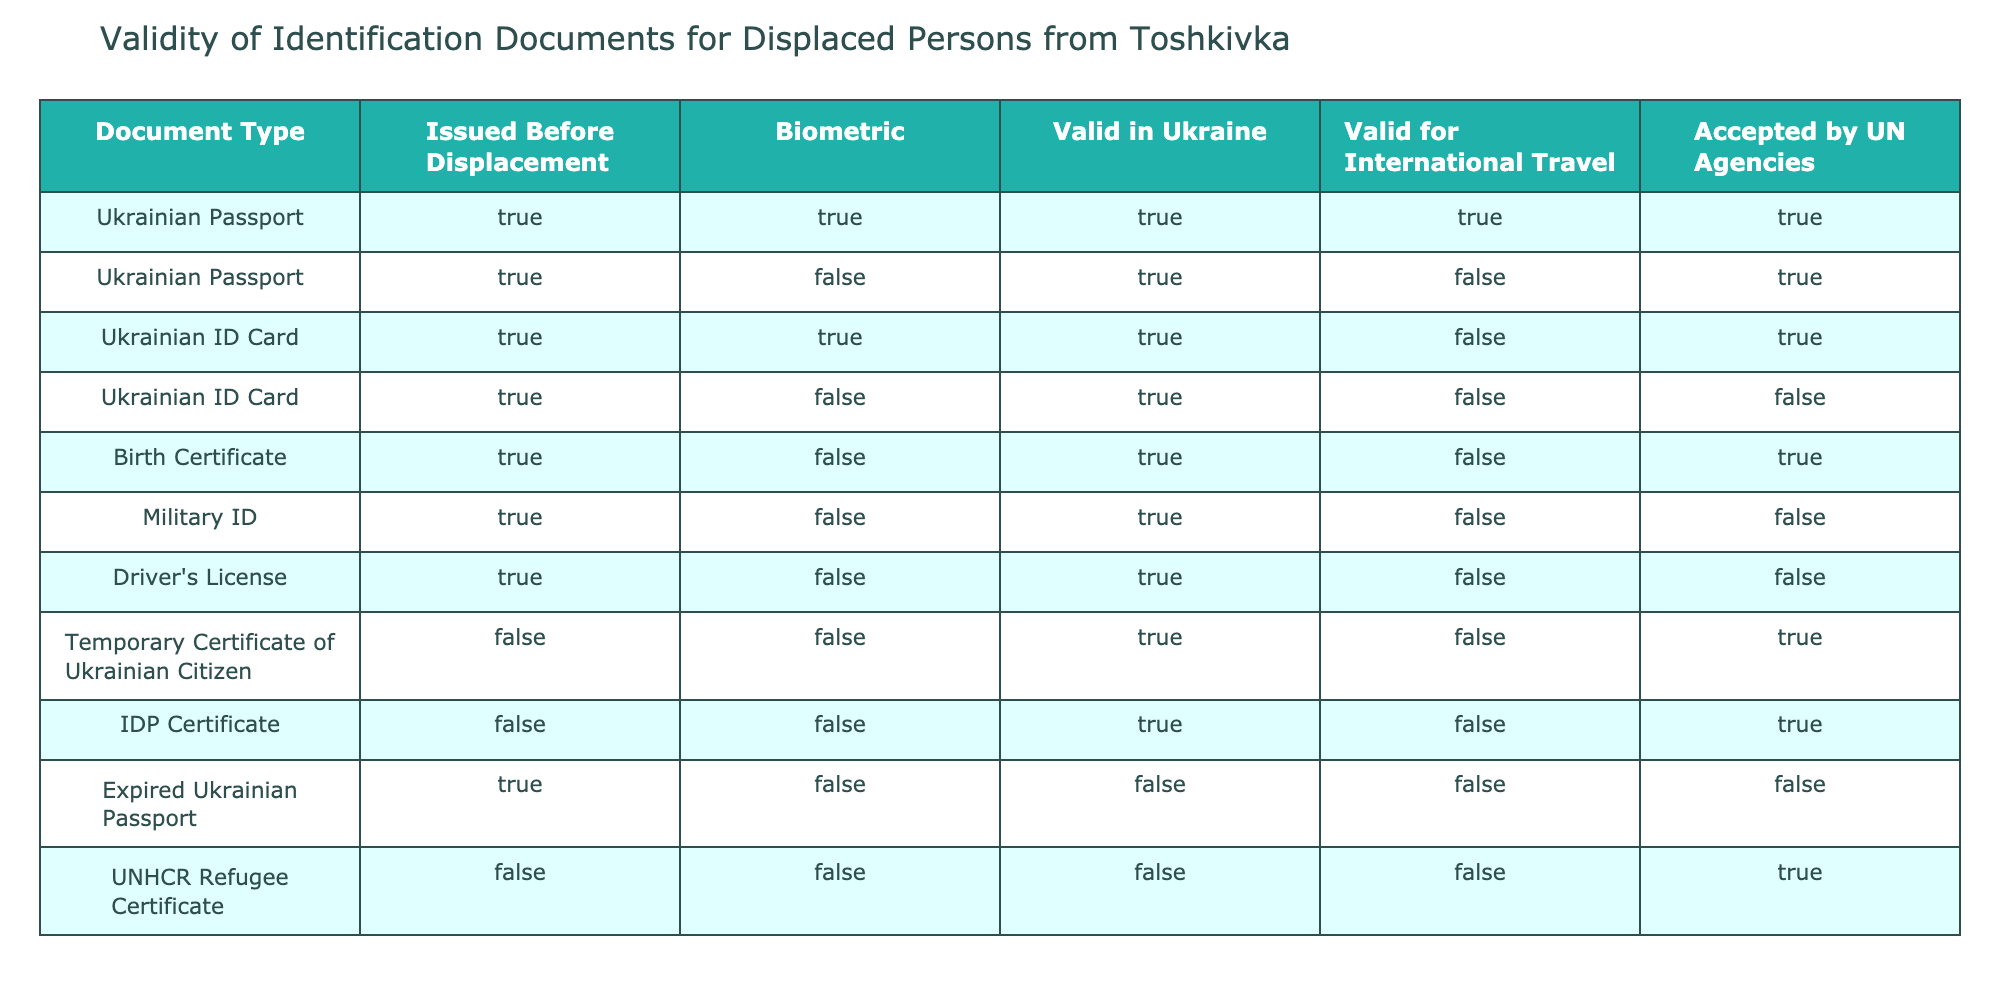What types of identification documents are valid in Ukraine? The table indicates that both Ukrainian Passports (both biometric and non-biometric) and Ukrainian ID Cards (only biometric) are valid in Ukraine. Additionally, the Temporary Certificate of Ukrainian Citizen and IDP Certificate are also valid in Ukraine.
Answer: Ukrainian Passport, Ukrainian ID Card, Temporary Certificate of Ukrainian Citizen, IDP Certificate Is the Ukrainian Birth Certificate accepted by UN agencies? The table shows that the Ukrainian Birth Certificate is accepted by UN agencies despite being marked as not valid for international travel. This is evident from the "Accepted by UN Agencies" column, which has a "TRUE" value for the Birth Certificate row.
Answer: Yes How many documents are valid for international travel? The documents that are valid for international travel include the Ukrainian Passport (biometric), Ukrainian Passport (non-biometric), and the IDP Certificate, totaling three valid documents.
Answer: 3 Does a military ID issued before displacement have validity in Ukraine? According to the table, the military ID, even though it was issued before displacement, is valid in Ukraine as shown in the "Valid in Ukraine" column marked TRUE.
Answer: Yes Which document types are not valid for international travel? By examining the table, the documents that are not valid for international travel include the Ukrainian ID Card (non-biometric), Birth Certificate, Military ID, Driver's License, Temporary Certificate of Ukrainian Citizen, IDP Certificate, Expired Ukrainian Passport, and UNHCR Refugee Certificate. There are a total of 8 documents in this category.
Answer: 8 Is the expired Ukrainian passport accepted by UN agencies? The table specifies that the expired Ukrainian passport is not accepted by UN agencies, as indicated by the FALSE value under the "Accepted by UN Agencies" column.
Answer: No What is the only document type that is both valid in Ukraine and accepted by UN agencies but not valid for international travel? The IDP Certificate is the only document that is valid in Ukraine and accepted by UN agencies while being marked as not valid for international travel.
Answer: IDP Certificate Which document has the maximum number of conditions met (TRUE values)? The Ukrainian Passport (biometric) meets all five conditions, with TRUE values for each category in the table, making it the document with the maximum conditions met.
Answer: Ukrainian Passport (biometric) 